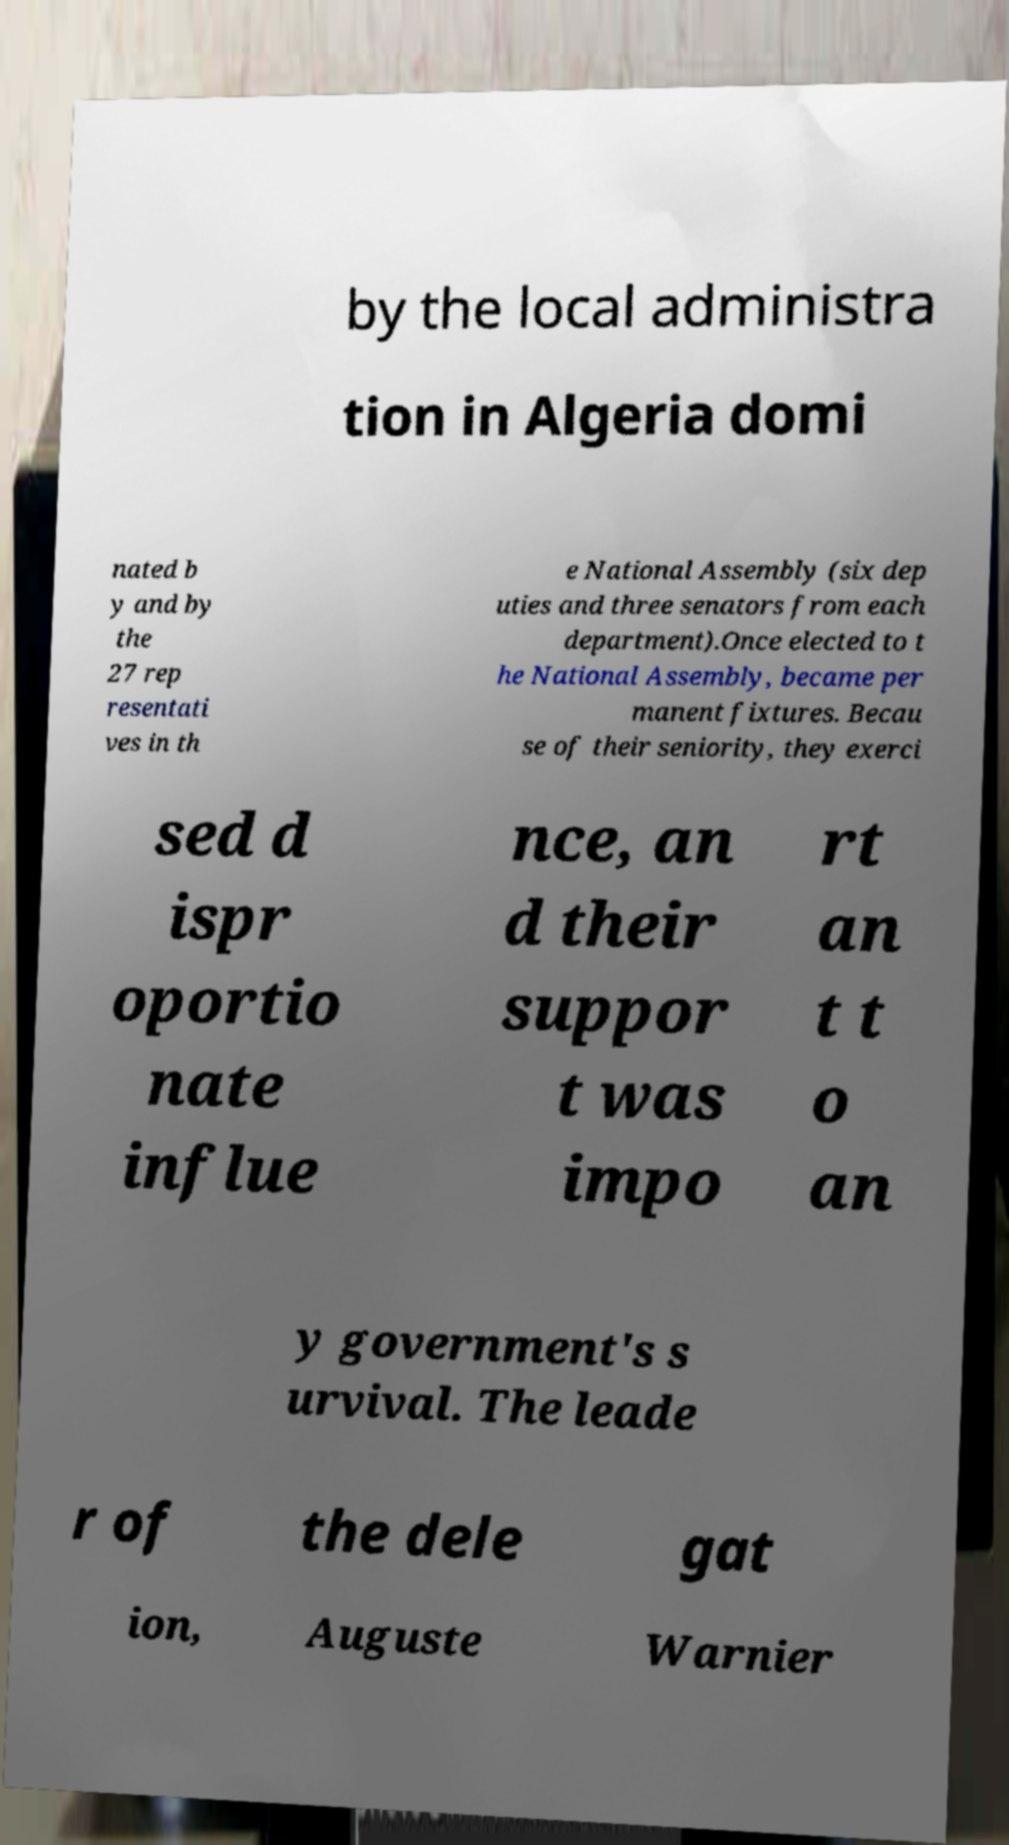What messages or text are displayed in this image? I need them in a readable, typed format. by the local administra tion in Algeria domi nated b y and by the 27 rep resentati ves in th e National Assembly (six dep uties and three senators from each department).Once elected to t he National Assembly, became per manent fixtures. Becau se of their seniority, they exerci sed d ispr oportio nate influe nce, an d their suppor t was impo rt an t t o an y government's s urvival. The leade r of the dele gat ion, Auguste Warnier 